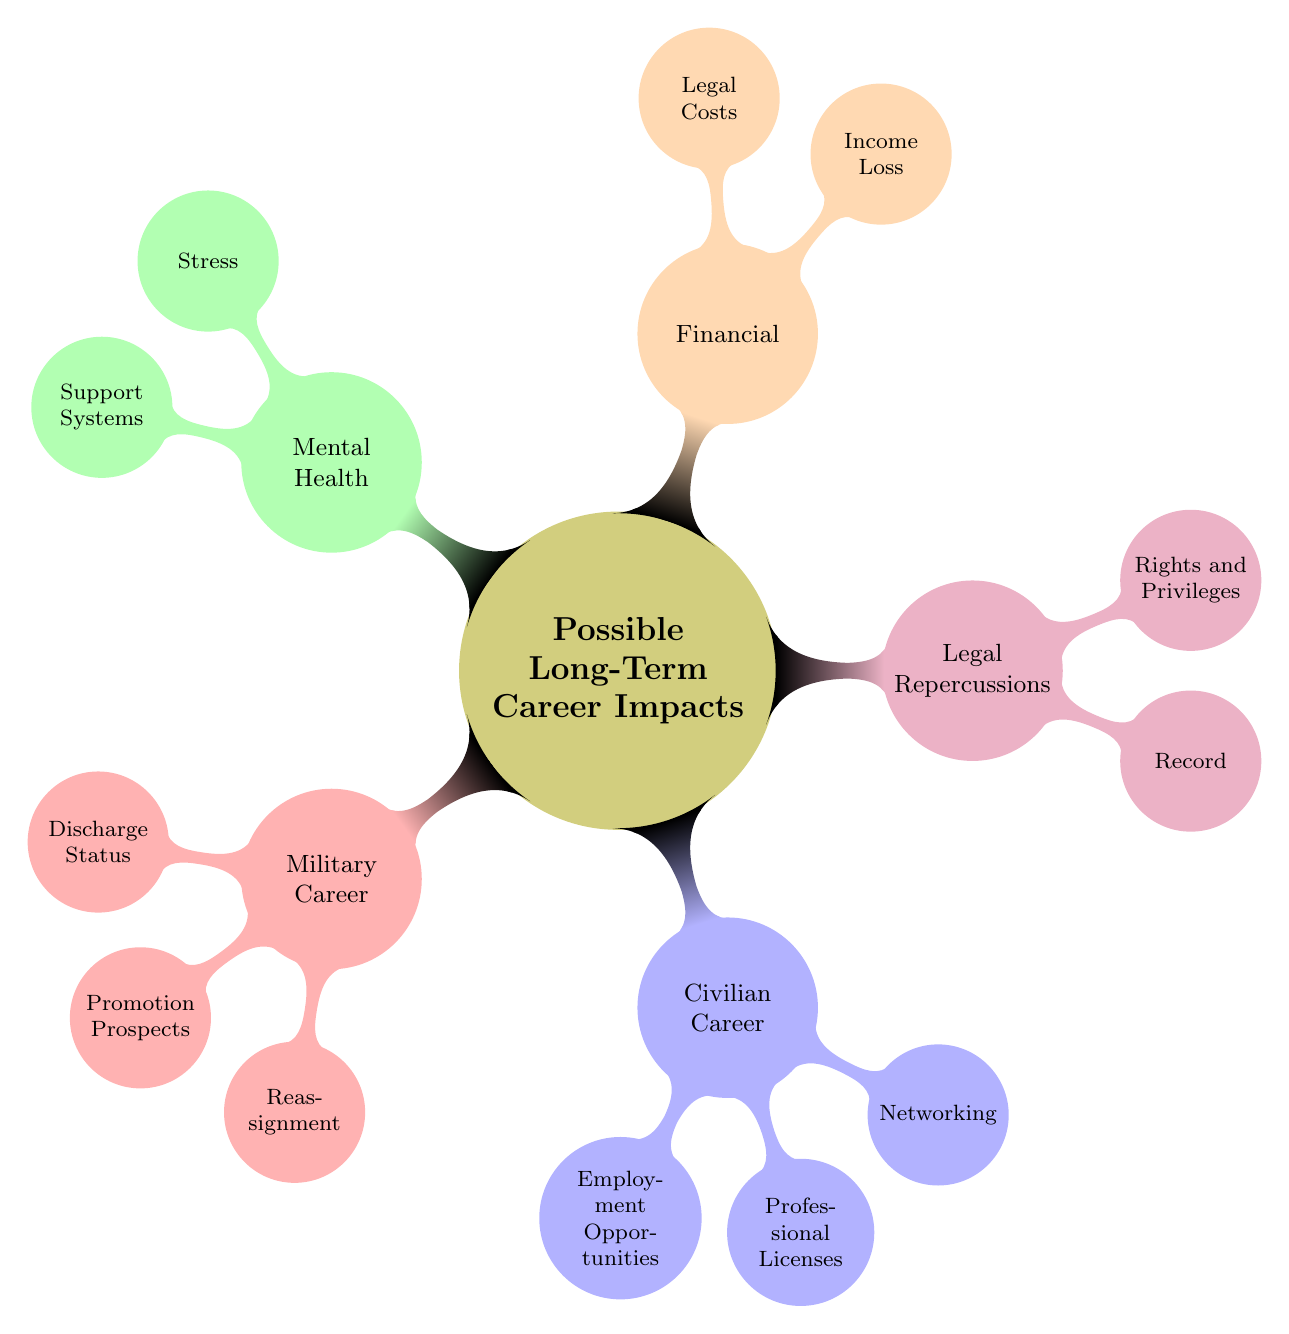What are the three categories of long-term career impacts listed in the diagram? The diagram lists "Military Career," "Civilian Career," and "Legal Repercussions," among others.
Answer: Military Career, Civilian Career, Legal Repercussions How many sub-nodes are there under "Civilian Career"? Under "Civilian Career," there are three sub-nodes: "Employment Opportunities," "Professional Licenses," and "Networking."
Answer: Three What is the impact of a "Dishonorable Discharge" on "Promotion Prospects"? A "Dishonorable Discharge" leads to "Limited or Non-Existent" promotion prospects as shown in the diagram.
Answer: Limited or Non-Existent Which category is related to "Ongoing Legal Fees"? "Ongoing Legal Fees" is related to the "Financial" category in the diagram.
Answer: Financial How do "Reduced Access to Military Mental Health Resources" and "Strained Family Relationships" relate to mental health? Both "Reduced Access to Military Mental Health Resources" and "Strained Family Relationships" are classified under "Mental Health," indicating possible mental health challenges.
Answer: Mental Health What are the two aspects of "Record" mentioned under "Legal Repercussions"? The two aspects of "Record" mentioned are "Permanent Criminal Record" and "Public Court Records."
Answer: Permanent Criminal Record, Public Court Records What node would you find information about "Challenges in Obtaining Professional Licenses"? Information about "Challenges in Obtaining Professional Licenses" can be found under the "Civilian Career" node.
Answer: Civilian Career Name one potential outcome of being accused of a crime in terms of "Income Loss." One potential outcome is "Reduction in Pension," which is specified in the "Financial" category.
Answer: Reduction in Pension 